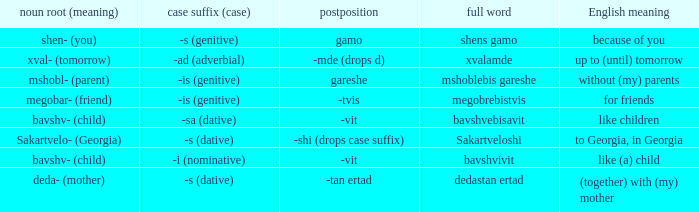Could you parse the entire table? {'header': ['noun root (meaning)', 'case suffix (case)', 'postposition', 'full word', 'English meaning'], 'rows': [['shen- (you)', '-s (genitive)', 'gamo', 'shens gamo', 'because of you'], ['xval- (tomorrow)', '-ad (adverbial)', '-mde (drops d)', 'xvalamde', 'up to (until) tomorrow'], ['mshobl- (parent)', '-is (genitive)', 'gareshe', 'mshoblebis gareshe', 'without (my) parents'], ['megobar- (friend)', '-is (genitive)', '-tvis', 'megobrebistvis', 'for friends'], ['bavshv- (child)', '-sa (dative)', '-vit', 'bavshvebisavit', 'like children'], ['Sakartvelo- (Georgia)', '-s (dative)', '-shi (drops case suffix)', 'Sakartveloshi', 'to Georgia, in Georgia'], ['bavshv- (child)', '-i (nominative)', '-vit', 'bavshvivit', 'like (a) child'], ['deda- (mother)', '-s (dative)', '-tan ertad', 'dedastan ertad', '(together) with (my) mother']]} What is the Full Word, when Case Suffix (case) is "-sa (dative)"? Bavshvebisavit. 